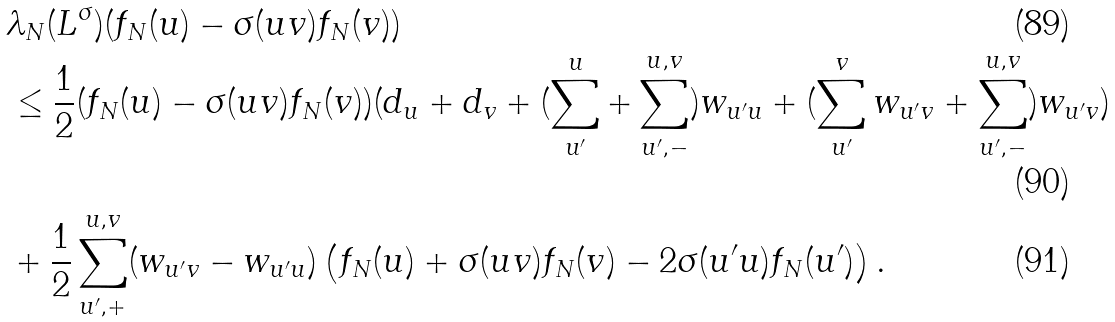<formula> <loc_0><loc_0><loc_500><loc_500>& \lambda _ { N } ( L ^ { \sigma } ) ( f _ { N } ( u ) - \sigma ( u v ) f _ { N } ( v ) ) \\ & \leq \frac { 1 } { 2 } ( f _ { N } ( u ) - \sigma ( u v ) f _ { N } ( v ) ) ( d _ { u } + d _ { v } + ( \sum _ { u ^ { \prime } } ^ { u } + \sum _ { u ^ { \prime } , - } ^ { u , v } ) w _ { u ^ { \prime } u } + ( \sum _ { u ^ { \prime } } ^ { v } w _ { u ^ { \prime } v } + \sum _ { u ^ { \prime } , - } ^ { u , v } ) w _ { u ^ { \prime } v } ) \\ & + \frac { 1 } { 2 } \sum _ { u ^ { \prime } , + } ^ { u , v } ( w _ { u ^ { \prime } v } - w _ { u ^ { \prime } u } ) \left ( f _ { N } ( u ) + \sigma ( u v ) f _ { N } ( v ) - 2 \sigma ( u ^ { \prime } u ) f _ { N } ( u ^ { \prime } ) \right ) .</formula> 